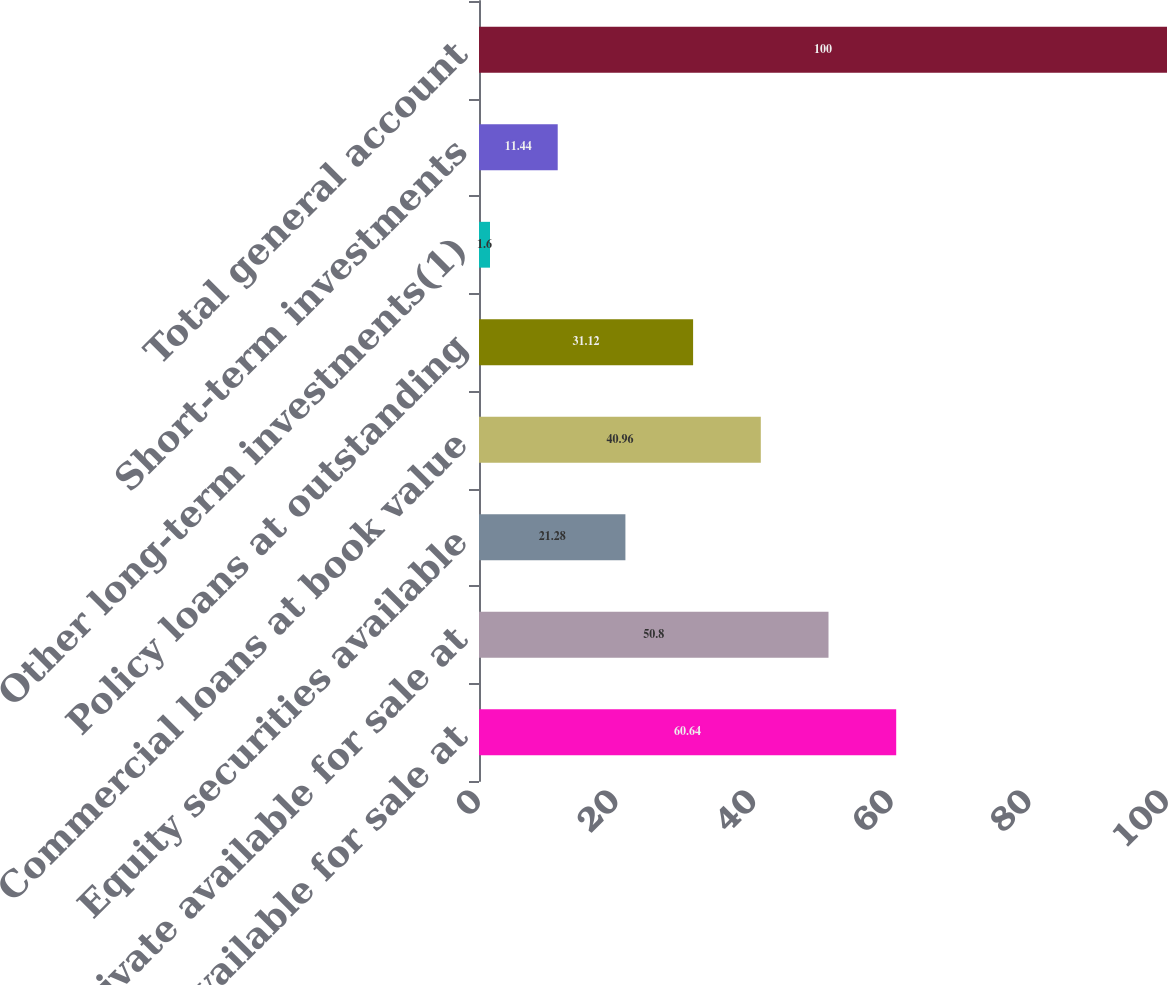Convert chart. <chart><loc_0><loc_0><loc_500><loc_500><bar_chart><fcel>Public available for sale at<fcel>Private available for sale at<fcel>Equity securities available<fcel>Commercial loans at book value<fcel>Policy loans at outstanding<fcel>Other long-term investments(1)<fcel>Short-term investments<fcel>Total general account<nl><fcel>60.64<fcel>50.8<fcel>21.28<fcel>40.96<fcel>31.12<fcel>1.6<fcel>11.44<fcel>100<nl></chart> 